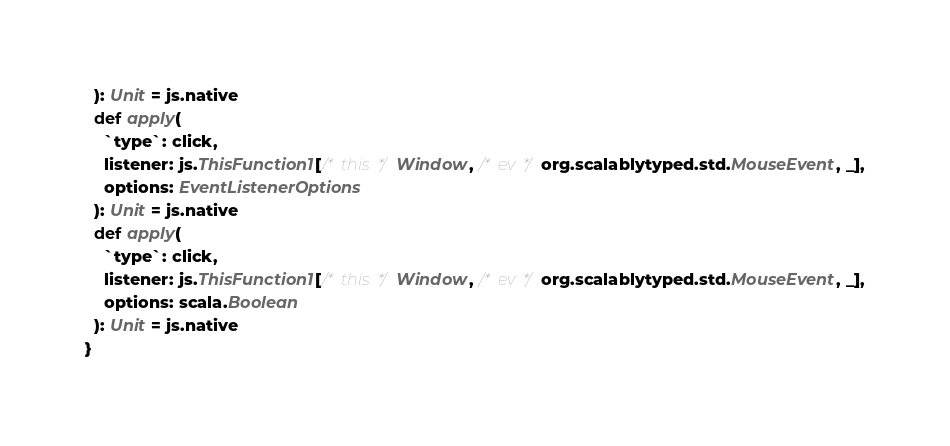<code> <loc_0><loc_0><loc_500><loc_500><_Scala_>  ): Unit = js.native
  def apply(
    `type`: click,
    listener: js.ThisFunction1[/* this */ Window, /* ev */ org.scalablytyped.std.MouseEvent, _],
    options: EventListenerOptions
  ): Unit = js.native
  def apply(
    `type`: click,
    listener: js.ThisFunction1[/* this */ Window, /* ev */ org.scalablytyped.std.MouseEvent, _],
    options: scala.Boolean
  ): Unit = js.native
}

</code> 